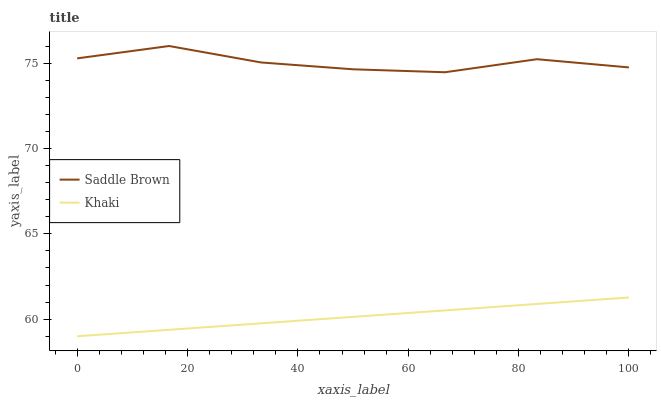Does Khaki have the minimum area under the curve?
Answer yes or no. Yes. Does Saddle Brown have the maximum area under the curve?
Answer yes or no. Yes. Does Saddle Brown have the minimum area under the curve?
Answer yes or no. No. Is Khaki the smoothest?
Answer yes or no. Yes. Is Saddle Brown the roughest?
Answer yes or no. Yes. Is Saddle Brown the smoothest?
Answer yes or no. No. Does Khaki have the lowest value?
Answer yes or no. Yes. Does Saddle Brown have the lowest value?
Answer yes or no. No. Does Saddle Brown have the highest value?
Answer yes or no. Yes. Is Khaki less than Saddle Brown?
Answer yes or no. Yes. Is Saddle Brown greater than Khaki?
Answer yes or no. Yes. Does Khaki intersect Saddle Brown?
Answer yes or no. No. 